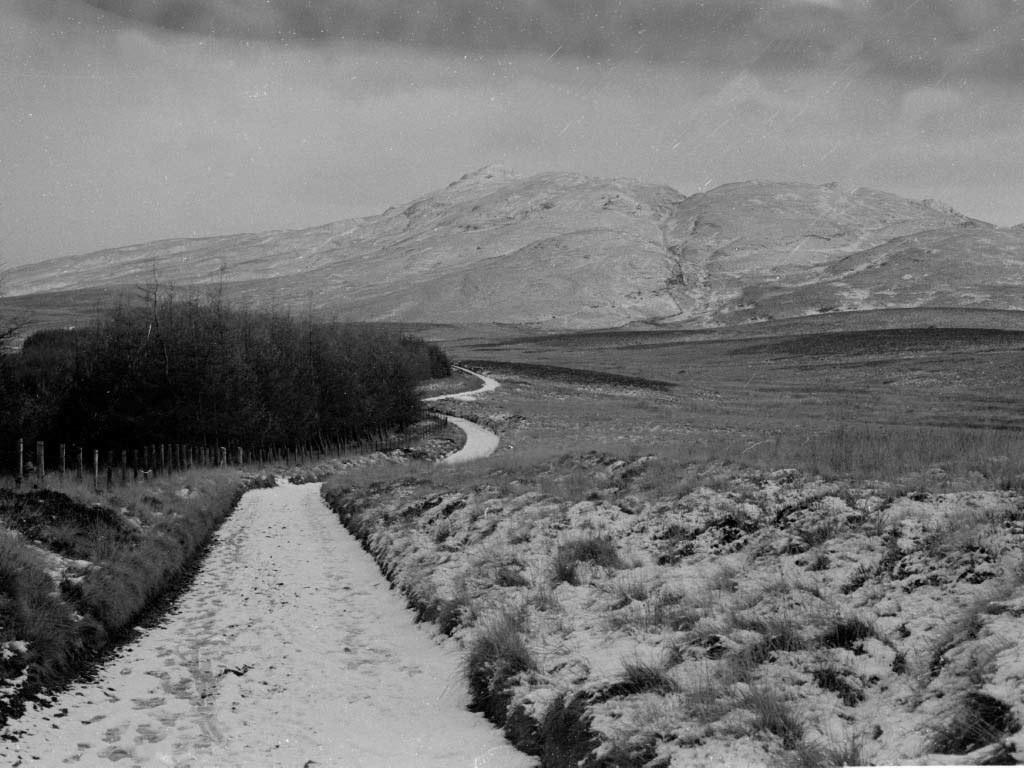What type of weather is depicted in the image? There is snow in the image, indicating a cold or wintery weather condition. What objects can be seen in the image? There are sticks and trees visible in the image. What type of vegetation is present in the image? There is grass in the image. What is visible in the background of the image? There is a mountain in the background of the image. What is visible at the top of the image? The sky is visible at the top of the image. What type of science experiment is being conducted in the image? There is no indication of a science experiment in the image; it depicts a snowy scene with trees, sticks, grass, a mountain, and the sky. 